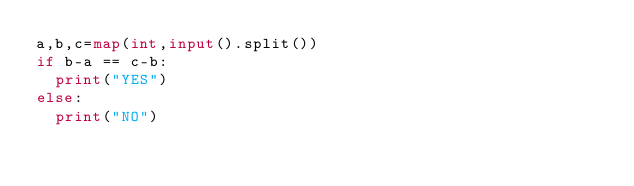<code> <loc_0><loc_0><loc_500><loc_500><_Python_>a,b,c=map(int,input().split())
if b-a == c-b:
  print("YES")
else:
  print("NO")</code> 